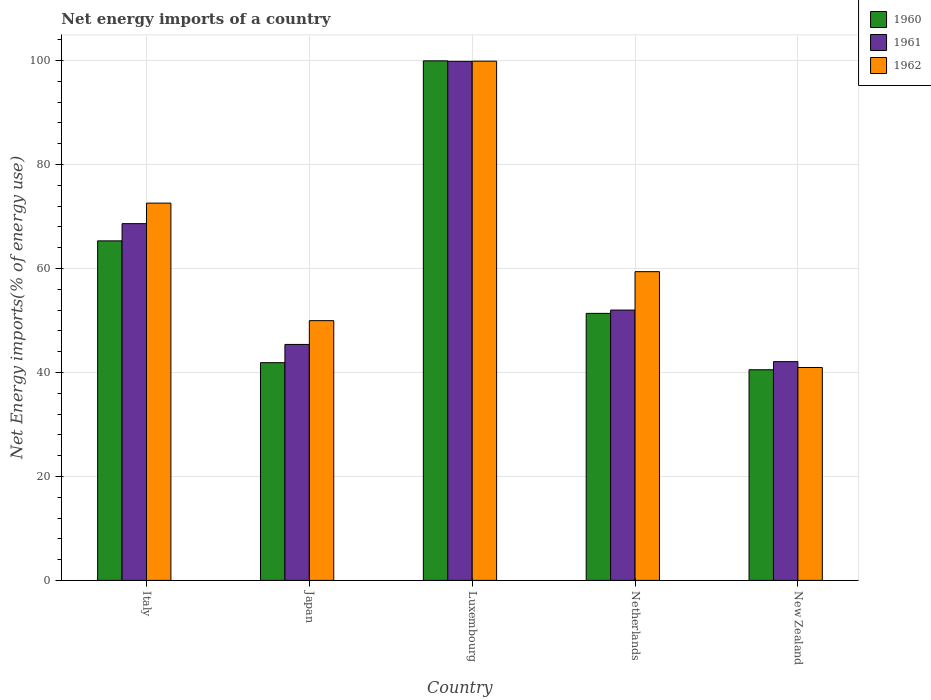How many bars are there on the 1st tick from the right?
Offer a very short reply. 3. What is the net energy imports in 1960 in New Zealand?
Give a very brief answer. 40.52. Across all countries, what is the maximum net energy imports in 1962?
Make the answer very short. 99.88. Across all countries, what is the minimum net energy imports in 1961?
Keep it short and to the point. 42.08. In which country was the net energy imports in 1962 maximum?
Your answer should be compact. Luxembourg. In which country was the net energy imports in 1961 minimum?
Provide a succinct answer. New Zealand. What is the total net energy imports in 1961 in the graph?
Your answer should be very brief. 307.97. What is the difference between the net energy imports in 1961 in Italy and that in Japan?
Your answer should be very brief. 23.24. What is the difference between the net energy imports in 1961 in Luxembourg and the net energy imports in 1960 in Japan?
Give a very brief answer. 57.97. What is the average net energy imports in 1961 per country?
Your response must be concise. 61.59. What is the difference between the net energy imports of/in 1961 and net energy imports of/in 1962 in New Zealand?
Give a very brief answer. 1.13. In how many countries, is the net energy imports in 1961 greater than 12 %?
Give a very brief answer. 5. What is the ratio of the net energy imports in 1962 in Luxembourg to that in Netherlands?
Your answer should be very brief. 1.68. Is the net energy imports in 1962 in Italy less than that in Netherlands?
Your response must be concise. No. What is the difference between the highest and the second highest net energy imports in 1961?
Your response must be concise. 31.22. What is the difference between the highest and the lowest net energy imports in 1961?
Ensure brevity in your answer.  57.77. In how many countries, is the net energy imports in 1960 greater than the average net energy imports in 1960 taken over all countries?
Provide a short and direct response. 2. What does the 2nd bar from the right in New Zealand represents?
Your answer should be compact. 1961. Is it the case that in every country, the sum of the net energy imports in 1961 and net energy imports in 1962 is greater than the net energy imports in 1960?
Keep it short and to the point. Yes. How many bars are there?
Make the answer very short. 15. Are all the bars in the graph horizontal?
Make the answer very short. No. Are the values on the major ticks of Y-axis written in scientific E-notation?
Offer a very short reply. No. Does the graph contain grids?
Keep it short and to the point. Yes. What is the title of the graph?
Your response must be concise. Net energy imports of a country. What is the label or title of the X-axis?
Make the answer very short. Country. What is the label or title of the Y-axis?
Provide a short and direct response. Net Energy imports(% of energy use). What is the Net Energy imports(% of energy use) of 1960 in Italy?
Offer a very short reply. 65.32. What is the Net Energy imports(% of energy use) in 1961 in Italy?
Your response must be concise. 68.63. What is the Net Energy imports(% of energy use) of 1962 in Italy?
Your answer should be compact. 72.58. What is the Net Energy imports(% of energy use) of 1960 in Japan?
Keep it short and to the point. 41.88. What is the Net Energy imports(% of energy use) of 1961 in Japan?
Make the answer very short. 45.39. What is the Net Energy imports(% of energy use) of 1962 in Japan?
Your answer should be very brief. 49.97. What is the Net Energy imports(% of energy use) of 1960 in Luxembourg?
Your response must be concise. 99.95. What is the Net Energy imports(% of energy use) in 1961 in Luxembourg?
Your answer should be very brief. 99.85. What is the Net Energy imports(% of energy use) of 1962 in Luxembourg?
Give a very brief answer. 99.88. What is the Net Energy imports(% of energy use) in 1960 in Netherlands?
Your response must be concise. 51.37. What is the Net Energy imports(% of energy use) of 1961 in Netherlands?
Make the answer very short. 52. What is the Net Energy imports(% of energy use) in 1962 in Netherlands?
Ensure brevity in your answer.  59.39. What is the Net Energy imports(% of energy use) of 1960 in New Zealand?
Offer a very short reply. 40.52. What is the Net Energy imports(% of energy use) of 1961 in New Zealand?
Ensure brevity in your answer.  42.08. What is the Net Energy imports(% of energy use) of 1962 in New Zealand?
Make the answer very short. 40.95. Across all countries, what is the maximum Net Energy imports(% of energy use) of 1960?
Your answer should be compact. 99.95. Across all countries, what is the maximum Net Energy imports(% of energy use) in 1961?
Offer a terse response. 99.85. Across all countries, what is the maximum Net Energy imports(% of energy use) of 1962?
Give a very brief answer. 99.88. Across all countries, what is the minimum Net Energy imports(% of energy use) in 1960?
Your answer should be compact. 40.52. Across all countries, what is the minimum Net Energy imports(% of energy use) in 1961?
Ensure brevity in your answer.  42.08. Across all countries, what is the minimum Net Energy imports(% of energy use) of 1962?
Your answer should be compact. 40.95. What is the total Net Energy imports(% of energy use) of 1960 in the graph?
Give a very brief answer. 299.04. What is the total Net Energy imports(% of energy use) in 1961 in the graph?
Provide a succinct answer. 307.97. What is the total Net Energy imports(% of energy use) of 1962 in the graph?
Your response must be concise. 322.78. What is the difference between the Net Energy imports(% of energy use) in 1960 in Italy and that in Japan?
Keep it short and to the point. 23.43. What is the difference between the Net Energy imports(% of energy use) in 1961 in Italy and that in Japan?
Provide a short and direct response. 23.24. What is the difference between the Net Energy imports(% of energy use) of 1962 in Italy and that in Japan?
Offer a terse response. 22.61. What is the difference between the Net Energy imports(% of energy use) of 1960 in Italy and that in Luxembourg?
Your response must be concise. -34.63. What is the difference between the Net Energy imports(% of energy use) of 1961 in Italy and that in Luxembourg?
Provide a succinct answer. -31.22. What is the difference between the Net Energy imports(% of energy use) of 1962 in Italy and that in Luxembourg?
Give a very brief answer. -27.31. What is the difference between the Net Energy imports(% of energy use) of 1960 in Italy and that in Netherlands?
Your answer should be compact. 13.95. What is the difference between the Net Energy imports(% of energy use) in 1961 in Italy and that in Netherlands?
Keep it short and to the point. 16.63. What is the difference between the Net Energy imports(% of energy use) of 1962 in Italy and that in Netherlands?
Your answer should be compact. 13.19. What is the difference between the Net Energy imports(% of energy use) in 1960 in Italy and that in New Zealand?
Provide a succinct answer. 24.79. What is the difference between the Net Energy imports(% of energy use) in 1961 in Italy and that in New Zealand?
Ensure brevity in your answer.  26.55. What is the difference between the Net Energy imports(% of energy use) of 1962 in Italy and that in New Zealand?
Ensure brevity in your answer.  31.63. What is the difference between the Net Energy imports(% of energy use) of 1960 in Japan and that in Luxembourg?
Ensure brevity in your answer.  -58.07. What is the difference between the Net Energy imports(% of energy use) of 1961 in Japan and that in Luxembourg?
Offer a terse response. -54.46. What is the difference between the Net Energy imports(% of energy use) of 1962 in Japan and that in Luxembourg?
Provide a short and direct response. -49.92. What is the difference between the Net Energy imports(% of energy use) of 1960 in Japan and that in Netherlands?
Provide a short and direct response. -9.49. What is the difference between the Net Energy imports(% of energy use) in 1961 in Japan and that in Netherlands?
Ensure brevity in your answer.  -6.61. What is the difference between the Net Energy imports(% of energy use) of 1962 in Japan and that in Netherlands?
Your answer should be very brief. -9.42. What is the difference between the Net Energy imports(% of energy use) in 1960 in Japan and that in New Zealand?
Your answer should be very brief. 1.36. What is the difference between the Net Energy imports(% of energy use) in 1961 in Japan and that in New Zealand?
Keep it short and to the point. 3.31. What is the difference between the Net Energy imports(% of energy use) in 1962 in Japan and that in New Zealand?
Make the answer very short. 9.02. What is the difference between the Net Energy imports(% of energy use) in 1960 in Luxembourg and that in Netherlands?
Make the answer very short. 48.58. What is the difference between the Net Energy imports(% of energy use) of 1961 in Luxembourg and that in Netherlands?
Your answer should be very brief. 47.85. What is the difference between the Net Energy imports(% of energy use) in 1962 in Luxembourg and that in Netherlands?
Ensure brevity in your answer.  40.49. What is the difference between the Net Energy imports(% of energy use) in 1960 in Luxembourg and that in New Zealand?
Your response must be concise. 59.43. What is the difference between the Net Energy imports(% of energy use) in 1961 in Luxembourg and that in New Zealand?
Provide a succinct answer. 57.77. What is the difference between the Net Energy imports(% of energy use) in 1962 in Luxembourg and that in New Zealand?
Make the answer very short. 58.93. What is the difference between the Net Energy imports(% of energy use) of 1960 in Netherlands and that in New Zealand?
Your answer should be very brief. 10.85. What is the difference between the Net Energy imports(% of energy use) in 1961 in Netherlands and that in New Zealand?
Provide a succinct answer. 9.92. What is the difference between the Net Energy imports(% of energy use) in 1962 in Netherlands and that in New Zealand?
Provide a succinct answer. 18.44. What is the difference between the Net Energy imports(% of energy use) of 1960 in Italy and the Net Energy imports(% of energy use) of 1961 in Japan?
Your answer should be compact. 19.92. What is the difference between the Net Energy imports(% of energy use) in 1960 in Italy and the Net Energy imports(% of energy use) in 1962 in Japan?
Offer a terse response. 15.35. What is the difference between the Net Energy imports(% of energy use) of 1961 in Italy and the Net Energy imports(% of energy use) of 1962 in Japan?
Your answer should be very brief. 18.66. What is the difference between the Net Energy imports(% of energy use) of 1960 in Italy and the Net Energy imports(% of energy use) of 1961 in Luxembourg?
Give a very brief answer. -34.54. What is the difference between the Net Energy imports(% of energy use) of 1960 in Italy and the Net Energy imports(% of energy use) of 1962 in Luxembourg?
Ensure brevity in your answer.  -34.57. What is the difference between the Net Energy imports(% of energy use) in 1961 in Italy and the Net Energy imports(% of energy use) in 1962 in Luxembourg?
Provide a succinct answer. -31.25. What is the difference between the Net Energy imports(% of energy use) of 1960 in Italy and the Net Energy imports(% of energy use) of 1961 in Netherlands?
Ensure brevity in your answer.  13.31. What is the difference between the Net Energy imports(% of energy use) in 1960 in Italy and the Net Energy imports(% of energy use) in 1962 in Netherlands?
Offer a very short reply. 5.93. What is the difference between the Net Energy imports(% of energy use) of 1961 in Italy and the Net Energy imports(% of energy use) of 1962 in Netherlands?
Offer a very short reply. 9.24. What is the difference between the Net Energy imports(% of energy use) of 1960 in Italy and the Net Energy imports(% of energy use) of 1961 in New Zealand?
Give a very brief answer. 23.23. What is the difference between the Net Energy imports(% of energy use) in 1960 in Italy and the Net Energy imports(% of energy use) in 1962 in New Zealand?
Ensure brevity in your answer.  24.36. What is the difference between the Net Energy imports(% of energy use) of 1961 in Italy and the Net Energy imports(% of energy use) of 1962 in New Zealand?
Offer a terse response. 27.68. What is the difference between the Net Energy imports(% of energy use) of 1960 in Japan and the Net Energy imports(% of energy use) of 1961 in Luxembourg?
Offer a very short reply. -57.97. What is the difference between the Net Energy imports(% of energy use) in 1960 in Japan and the Net Energy imports(% of energy use) in 1962 in Luxembourg?
Offer a terse response. -58. What is the difference between the Net Energy imports(% of energy use) in 1961 in Japan and the Net Energy imports(% of energy use) in 1962 in Luxembourg?
Make the answer very short. -54.49. What is the difference between the Net Energy imports(% of energy use) in 1960 in Japan and the Net Energy imports(% of energy use) in 1961 in Netherlands?
Keep it short and to the point. -10.12. What is the difference between the Net Energy imports(% of energy use) in 1960 in Japan and the Net Energy imports(% of energy use) in 1962 in Netherlands?
Provide a succinct answer. -17.51. What is the difference between the Net Energy imports(% of energy use) in 1961 in Japan and the Net Energy imports(% of energy use) in 1962 in Netherlands?
Ensure brevity in your answer.  -14. What is the difference between the Net Energy imports(% of energy use) in 1960 in Japan and the Net Energy imports(% of energy use) in 1961 in New Zealand?
Your answer should be very brief. -0.2. What is the difference between the Net Energy imports(% of energy use) in 1960 in Japan and the Net Energy imports(% of energy use) in 1962 in New Zealand?
Provide a short and direct response. 0.93. What is the difference between the Net Energy imports(% of energy use) of 1961 in Japan and the Net Energy imports(% of energy use) of 1962 in New Zealand?
Offer a very short reply. 4.44. What is the difference between the Net Energy imports(% of energy use) of 1960 in Luxembourg and the Net Energy imports(% of energy use) of 1961 in Netherlands?
Provide a short and direct response. 47.94. What is the difference between the Net Energy imports(% of energy use) of 1960 in Luxembourg and the Net Energy imports(% of energy use) of 1962 in Netherlands?
Ensure brevity in your answer.  40.56. What is the difference between the Net Energy imports(% of energy use) of 1961 in Luxembourg and the Net Energy imports(% of energy use) of 1962 in Netherlands?
Ensure brevity in your answer.  40.46. What is the difference between the Net Energy imports(% of energy use) of 1960 in Luxembourg and the Net Energy imports(% of energy use) of 1961 in New Zealand?
Your answer should be very brief. 57.87. What is the difference between the Net Energy imports(% of energy use) of 1960 in Luxembourg and the Net Energy imports(% of energy use) of 1962 in New Zealand?
Make the answer very short. 58.99. What is the difference between the Net Energy imports(% of energy use) of 1961 in Luxembourg and the Net Energy imports(% of energy use) of 1962 in New Zealand?
Ensure brevity in your answer.  58.9. What is the difference between the Net Energy imports(% of energy use) in 1960 in Netherlands and the Net Energy imports(% of energy use) in 1961 in New Zealand?
Provide a short and direct response. 9.29. What is the difference between the Net Energy imports(% of energy use) of 1960 in Netherlands and the Net Energy imports(% of energy use) of 1962 in New Zealand?
Offer a terse response. 10.42. What is the difference between the Net Energy imports(% of energy use) in 1961 in Netherlands and the Net Energy imports(% of energy use) in 1962 in New Zealand?
Offer a terse response. 11.05. What is the average Net Energy imports(% of energy use) in 1960 per country?
Ensure brevity in your answer.  59.81. What is the average Net Energy imports(% of energy use) in 1961 per country?
Provide a short and direct response. 61.59. What is the average Net Energy imports(% of energy use) in 1962 per country?
Your answer should be compact. 64.56. What is the difference between the Net Energy imports(% of energy use) in 1960 and Net Energy imports(% of energy use) in 1961 in Italy?
Offer a terse response. -3.31. What is the difference between the Net Energy imports(% of energy use) of 1960 and Net Energy imports(% of energy use) of 1962 in Italy?
Offer a terse response. -7.26. What is the difference between the Net Energy imports(% of energy use) of 1961 and Net Energy imports(% of energy use) of 1962 in Italy?
Your answer should be compact. -3.95. What is the difference between the Net Energy imports(% of energy use) of 1960 and Net Energy imports(% of energy use) of 1961 in Japan?
Offer a very short reply. -3.51. What is the difference between the Net Energy imports(% of energy use) of 1960 and Net Energy imports(% of energy use) of 1962 in Japan?
Keep it short and to the point. -8.09. What is the difference between the Net Energy imports(% of energy use) of 1961 and Net Energy imports(% of energy use) of 1962 in Japan?
Provide a succinct answer. -4.57. What is the difference between the Net Energy imports(% of energy use) of 1960 and Net Energy imports(% of energy use) of 1961 in Luxembourg?
Your answer should be very brief. 0.09. What is the difference between the Net Energy imports(% of energy use) of 1960 and Net Energy imports(% of energy use) of 1962 in Luxembourg?
Offer a terse response. 0.06. What is the difference between the Net Energy imports(% of energy use) of 1961 and Net Energy imports(% of energy use) of 1962 in Luxembourg?
Your answer should be compact. -0.03. What is the difference between the Net Energy imports(% of energy use) in 1960 and Net Energy imports(% of energy use) in 1961 in Netherlands?
Your answer should be compact. -0.64. What is the difference between the Net Energy imports(% of energy use) in 1960 and Net Energy imports(% of energy use) in 1962 in Netherlands?
Ensure brevity in your answer.  -8.02. What is the difference between the Net Energy imports(% of energy use) in 1961 and Net Energy imports(% of energy use) in 1962 in Netherlands?
Your response must be concise. -7.39. What is the difference between the Net Energy imports(% of energy use) of 1960 and Net Energy imports(% of energy use) of 1961 in New Zealand?
Your answer should be very brief. -1.56. What is the difference between the Net Energy imports(% of energy use) in 1960 and Net Energy imports(% of energy use) in 1962 in New Zealand?
Your response must be concise. -0.43. What is the difference between the Net Energy imports(% of energy use) of 1961 and Net Energy imports(% of energy use) of 1962 in New Zealand?
Make the answer very short. 1.13. What is the ratio of the Net Energy imports(% of energy use) of 1960 in Italy to that in Japan?
Provide a short and direct response. 1.56. What is the ratio of the Net Energy imports(% of energy use) of 1961 in Italy to that in Japan?
Your response must be concise. 1.51. What is the ratio of the Net Energy imports(% of energy use) of 1962 in Italy to that in Japan?
Offer a terse response. 1.45. What is the ratio of the Net Energy imports(% of energy use) in 1960 in Italy to that in Luxembourg?
Make the answer very short. 0.65. What is the ratio of the Net Energy imports(% of energy use) of 1961 in Italy to that in Luxembourg?
Make the answer very short. 0.69. What is the ratio of the Net Energy imports(% of energy use) of 1962 in Italy to that in Luxembourg?
Provide a short and direct response. 0.73. What is the ratio of the Net Energy imports(% of energy use) of 1960 in Italy to that in Netherlands?
Your answer should be very brief. 1.27. What is the ratio of the Net Energy imports(% of energy use) of 1961 in Italy to that in Netherlands?
Your answer should be very brief. 1.32. What is the ratio of the Net Energy imports(% of energy use) in 1962 in Italy to that in Netherlands?
Your answer should be compact. 1.22. What is the ratio of the Net Energy imports(% of energy use) in 1960 in Italy to that in New Zealand?
Offer a very short reply. 1.61. What is the ratio of the Net Energy imports(% of energy use) of 1961 in Italy to that in New Zealand?
Keep it short and to the point. 1.63. What is the ratio of the Net Energy imports(% of energy use) of 1962 in Italy to that in New Zealand?
Your response must be concise. 1.77. What is the ratio of the Net Energy imports(% of energy use) of 1960 in Japan to that in Luxembourg?
Ensure brevity in your answer.  0.42. What is the ratio of the Net Energy imports(% of energy use) of 1961 in Japan to that in Luxembourg?
Your response must be concise. 0.45. What is the ratio of the Net Energy imports(% of energy use) in 1962 in Japan to that in Luxembourg?
Offer a very short reply. 0.5. What is the ratio of the Net Energy imports(% of energy use) of 1960 in Japan to that in Netherlands?
Your answer should be compact. 0.82. What is the ratio of the Net Energy imports(% of energy use) of 1961 in Japan to that in Netherlands?
Provide a succinct answer. 0.87. What is the ratio of the Net Energy imports(% of energy use) of 1962 in Japan to that in Netherlands?
Make the answer very short. 0.84. What is the ratio of the Net Energy imports(% of energy use) in 1960 in Japan to that in New Zealand?
Ensure brevity in your answer.  1.03. What is the ratio of the Net Energy imports(% of energy use) in 1961 in Japan to that in New Zealand?
Your answer should be very brief. 1.08. What is the ratio of the Net Energy imports(% of energy use) in 1962 in Japan to that in New Zealand?
Give a very brief answer. 1.22. What is the ratio of the Net Energy imports(% of energy use) of 1960 in Luxembourg to that in Netherlands?
Keep it short and to the point. 1.95. What is the ratio of the Net Energy imports(% of energy use) of 1961 in Luxembourg to that in Netherlands?
Offer a very short reply. 1.92. What is the ratio of the Net Energy imports(% of energy use) in 1962 in Luxembourg to that in Netherlands?
Make the answer very short. 1.68. What is the ratio of the Net Energy imports(% of energy use) of 1960 in Luxembourg to that in New Zealand?
Offer a terse response. 2.47. What is the ratio of the Net Energy imports(% of energy use) of 1961 in Luxembourg to that in New Zealand?
Ensure brevity in your answer.  2.37. What is the ratio of the Net Energy imports(% of energy use) of 1962 in Luxembourg to that in New Zealand?
Give a very brief answer. 2.44. What is the ratio of the Net Energy imports(% of energy use) in 1960 in Netherlands to that in New Zealand?
Your answer should be very brief. 1.27. What is the ratio of the Net Energy imports(% of energy use) of 1961 in Netherlands to that in New Zealand?
Give a very brief answer. 1.24. What is the ratio of the Net Energy imports(% of energy use) of 1962 in Netherlands to that in New Zealand?
Offer a very short reply. 1.45. What is the difference between the highest and the second highest Net Energy imports(% of energy use) of 1960?
Give a very brief answer. 34.63. What is the difference between the highest and the second highest Net Energy imports(% of energy use) in 1961?
Provide a short and direct response. 31.22. What is the difference between the highest and the second highest Net Energy imports(% of energy use) in 1962?
Your answer should be compact. 27.31. What is the difference between the highest and the lowest Net Energy imports(% of energy use) in 1960?
Your response must be concise. 59.43. What is the difference between the highest and the lowest Net Energy imports(% of energy use) in 1961?
Your response must be concise. 57.77. What is the difference between the highest and the lowest Net Energy imports(% of energy use) of 1962?
Ensure brevity in your answer.  58.93. 